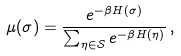<formula> <loc_0><loc_0><loc_500><loc_500>\mu ( \sigma ) = \frac { e ^ { - \beta H ( \sigma ) } } { \sum _ { \eta \in \mathcal { S } } e ^ { - \beta H ( \eta ) } } \, ,</formula> 